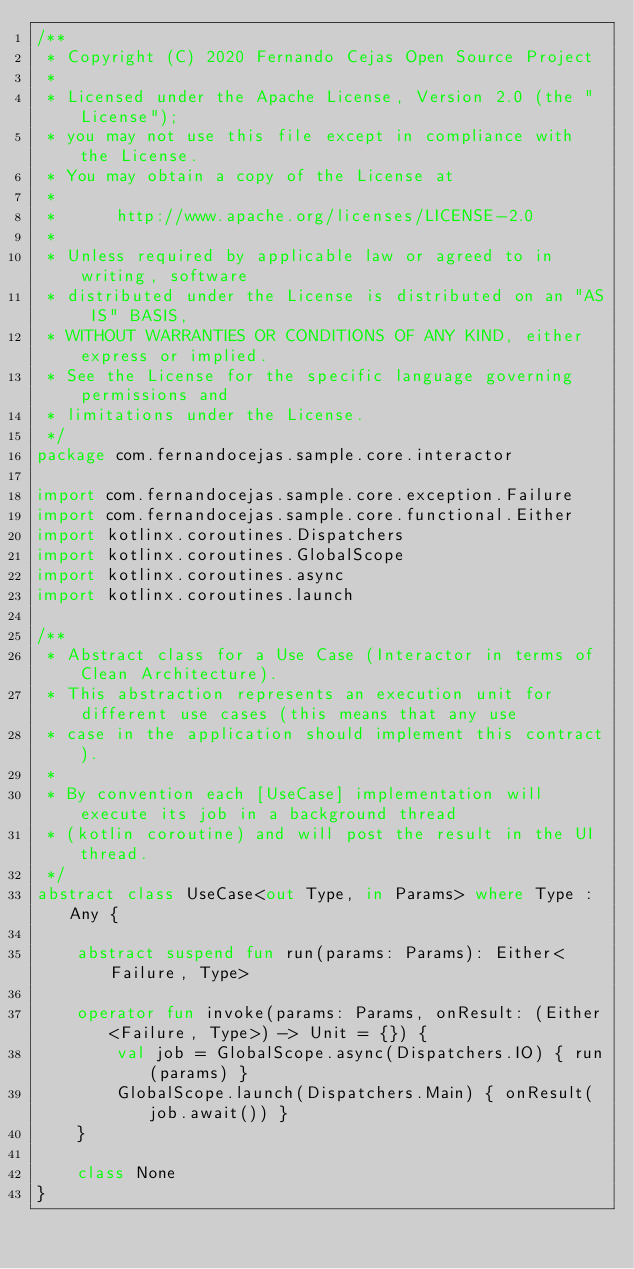<code> <loc_0><loc_0><loc_500><loc_500><_Kotlin_>/**
 * Copyright (C) 2020 Fernando Cejas Open Source Project
 *
 * Licensed under the Apache License, Version 2.0 (the "License");
 * you may not use this file except in compliance with the License.
 * You may obtain a copy of the License at
 *
 *      http://www.apache.org/licenses/LICENSE-2.0
 *
 * Unless required by applicable law or agreed to in writing, software
 * distributed under the License is distributed on an "AS IS" BASIS,
 * WITHOUT WARRANTIES OR CONDITIONS OF ANY KIND, either express or implied.
 * See the License for the specific language governing permissions and
 * limitations under the License.
 */
package com.fernandocejas.sample.core.interactor

import com.fernandocejas.sample.core.exception.Failure
import com.fernandocejas.sample.core.functional.Either
import kotlinx.coroutines.Dispatchers
import kotlinx.coroutines.GlobalScope
import kotlinx.coroutines.async
import kotlinx.coroutines.launch

/**
 * Abstract class for a Use Case (Interactor in terms of Clean Architecture).
 * This abstraction represents an execution unit for different use cases (this means that any use
 * case in the application should implement this contract).
 *
 * By convention each [UseCase] implementation will execute its job in a background thread
 * (kotlin coroutine) and will post the result in the UI thread.
 */
abstract class UseCase<out Type, in Params> where Type : Any {

    abstract suspend fun run(params: Params): Either<Failure, Type>

    operator fun invoke(params: Params, onResult: (Either<Failure, Type>) -> Unit = {}) {
        val job = GlobalScope.async(Dispatchers.IO) { run(params) }
        GlobalScope.launch(Dispatchers.Main) { onResult(job.await()) }
    }

    class None
}
</code> 